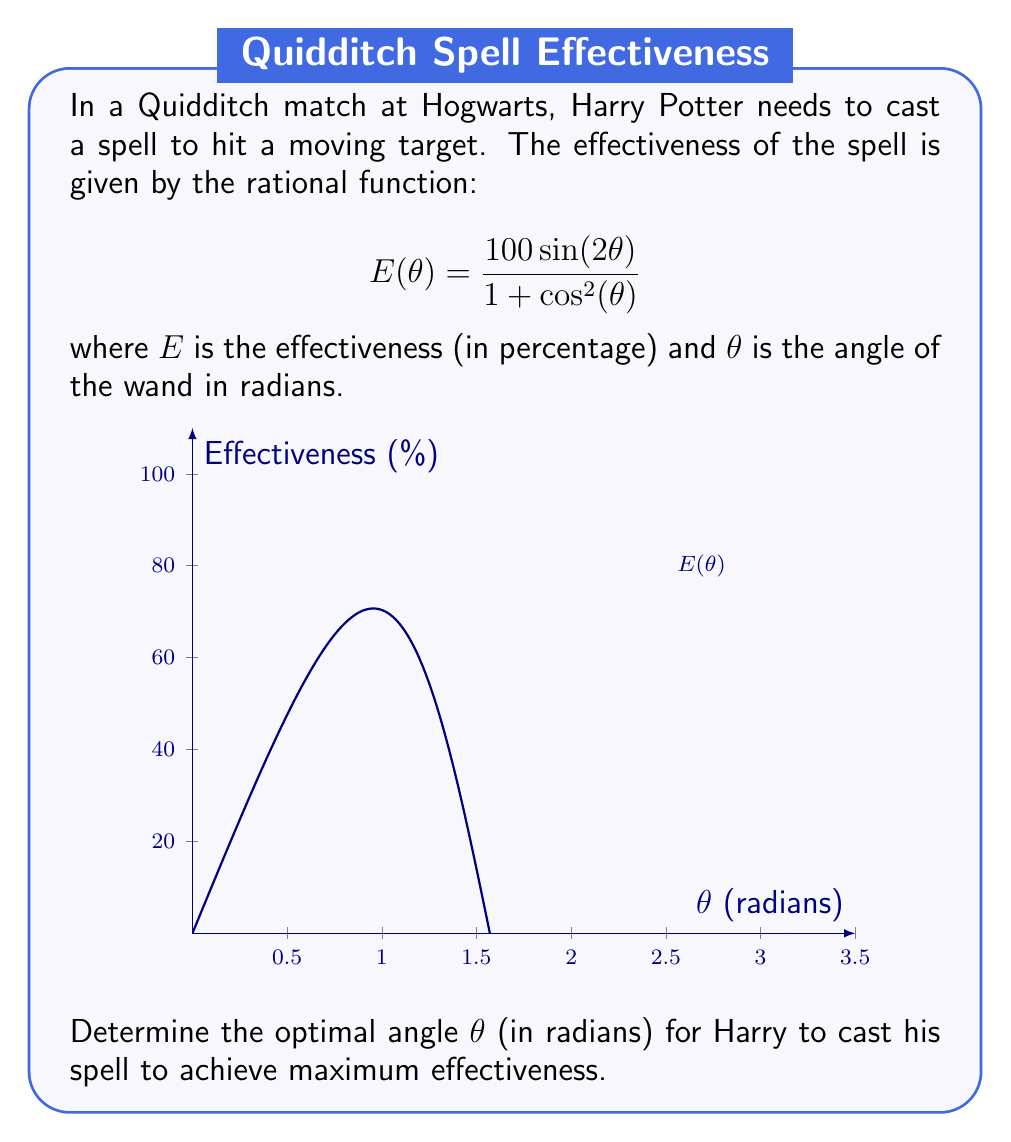Give your solution to this math problem. Let's approach this step-by-step:

1) To find the maximum of the function, we need to find where its derivative equals zero.

2) The derivative of $E(\theta)$ is:

   $$E'(\theta) = \frac{(100\sin(2\theta))'(1+\cos^2(\theta)) - 100\sin(2\theta)(1+\cos^2(\theta))'}{(1+\cos^2(\theta))^2}$$

3) Simplify:
   
   $$E'(\theta) = \frac{200\cos(2\theta)(1+\cos^2(\theta)) - 100\sin(2\theta)(-2\cos(\theta)\sin(\theta))}{(1+\cos^2(\theta))^2}$$

4) Set $E'(\theta) = 0$ and simplify:

   $$200\cos(2\theta)(1+\cos^2(\theta)) + 200\sin(2\theta)\cos(\theta)\sin(\theta) = 0$$

5) Use trigonometric identities:
   $\cos(2\theta) = \cos^2(\theta) - \sin^2(\theta)$
   $\sin(2\theta) = 2\sin(\theta)\cos(\theta)$

6) Substitute and simplify:

   $$200(\cos^2(\theta) - \sin^2(\theta))(1+\cos^2(\theta)) + 400\sin^2(\theta)\cos^2(\theta) = 0$$

7) This simplifies to:

   $$200\cos^2(\theta) - 200\sin^2(\theta) + 200\cos^4(\theta) - 200\sin^2(\theta)\cos^2(\theta) + 400\sin^2(\theta)\cos^2(\theta) = 0$$

8) Further simplification:

   $$200\cos^2(\theta) - 200\sin^2(\theta) + 200\cos^4(\theta) + 200\sin^2(\theta)\cos^2(\theta) = 0$$

9) Divide by 200:

   $$\cos^2(\theta) - \sin^2(\theta) + \cos^4(\theta) + \sin^2(\theta)\cos^2(\theta) = 0$$

10) Use $\sin^2(\theta) + \cos^2(\theta) = 1$:

    $$\cos^2(\theta) - (1-\cos^2(\theta)) + \cos^4(\theta) + (1-\cos^2(\theta))\cos^2(\theta) = 0$$

11) Simplify:

    $$2\cos^2(\theta) - 1 + \cos^4(\theta) = 0$$

12) Let $u = \cos^2(\theta)$:

    $$u^2 + 2u - 1 = 0$$

13) Solve this quadratic equation:

    $$u = \frac{-2 \pm \sqrt{4+4}}{2} = -1 \pm \sqrt{2}$$

14) Since $\cos^2(\theta)$ is always non-negative, we take the positive root:

    $$\cos^2(\theta) = -1 + \sqrt{2}$$

15) Solve for $\theta$:

    $$\theta = \arccos(\sqrt{-1 + \sqrt{2}}) \approx 0.955$$

This is the angle (in radians) that maximizes the effectiveness of the spell.
Answer: $\arccos(\sqrt{-1 + \sqrt{2}}) \approx 0.955$ radians 